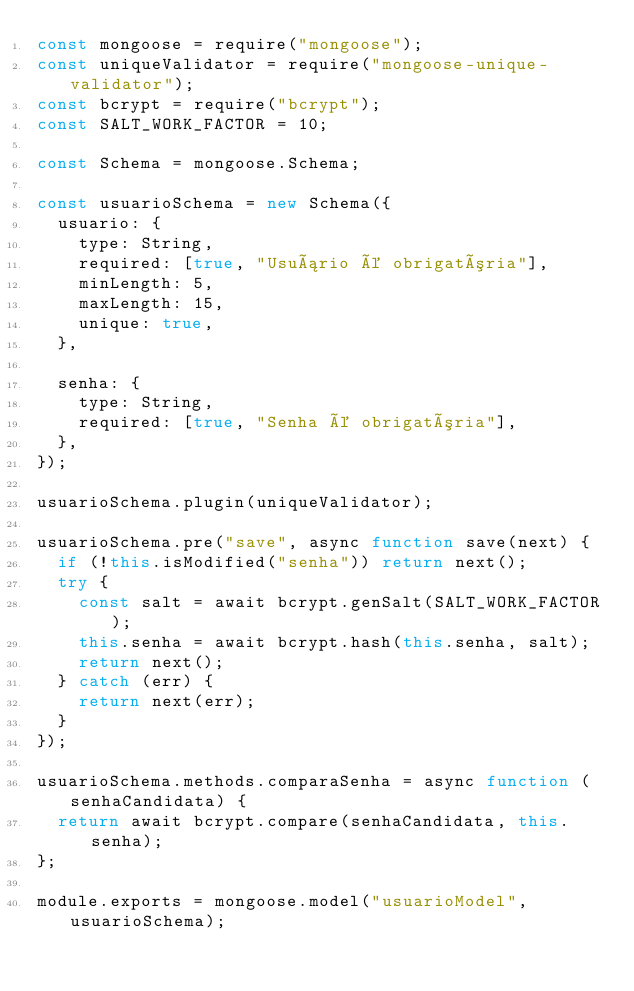Convert code to text. <code><loc_0><loc_0><loc_500><loc_500><_JavaScript_>const mongoose = require("mongoose");
const uniqueValidator = require("mongoose-unique-validator");
const bcrypt = require("bcrypt");
const SALT_WORK_FACTOR = 10;

const Schema = mongoose.Schema;

const usuarioSchema = new Schema({
  usuario: {
    type: String,
    required: [true, "Usuário é obrigatória"],
    minLength: 5,
    maxLength: 15,
    unique: true,
  },

  senha: {
    type: String,
    required: [true, "Senha é obrigatória"],
  },
});

usuarioSchema.plugin(uniqueValidator);

usuarioSchema.pre("save", async function save(next) {
  if (!this.isModified("senha")) return next();
  try {
    const salt = await bcrypt.genSalt(SALT_WORK_FACTOR);
    this.senha = await bcrypt.hash(this.senha, salt);
    return next();
  } catch (err) {
    return next(err);
  }
});

usuarioSchema.methods.comparaSenha = async function (senhaCandidata) {
  return await bcrypt.compare(senhaCandidata, this.senha);
};

module.exports = mongoose.model("usuarioModel", usuarioSchema);
</code> 